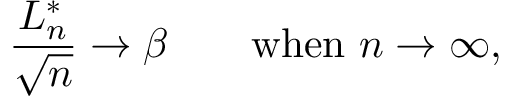Convert formula to latex. <formula><loc_0><loc_0><loc_500><loc_500>{ \frac { L _ { n } ^ { * } } { \sqrt { n } } } \rightarrow \beta \quad { w h e n } n \to \infty ,</formula> 